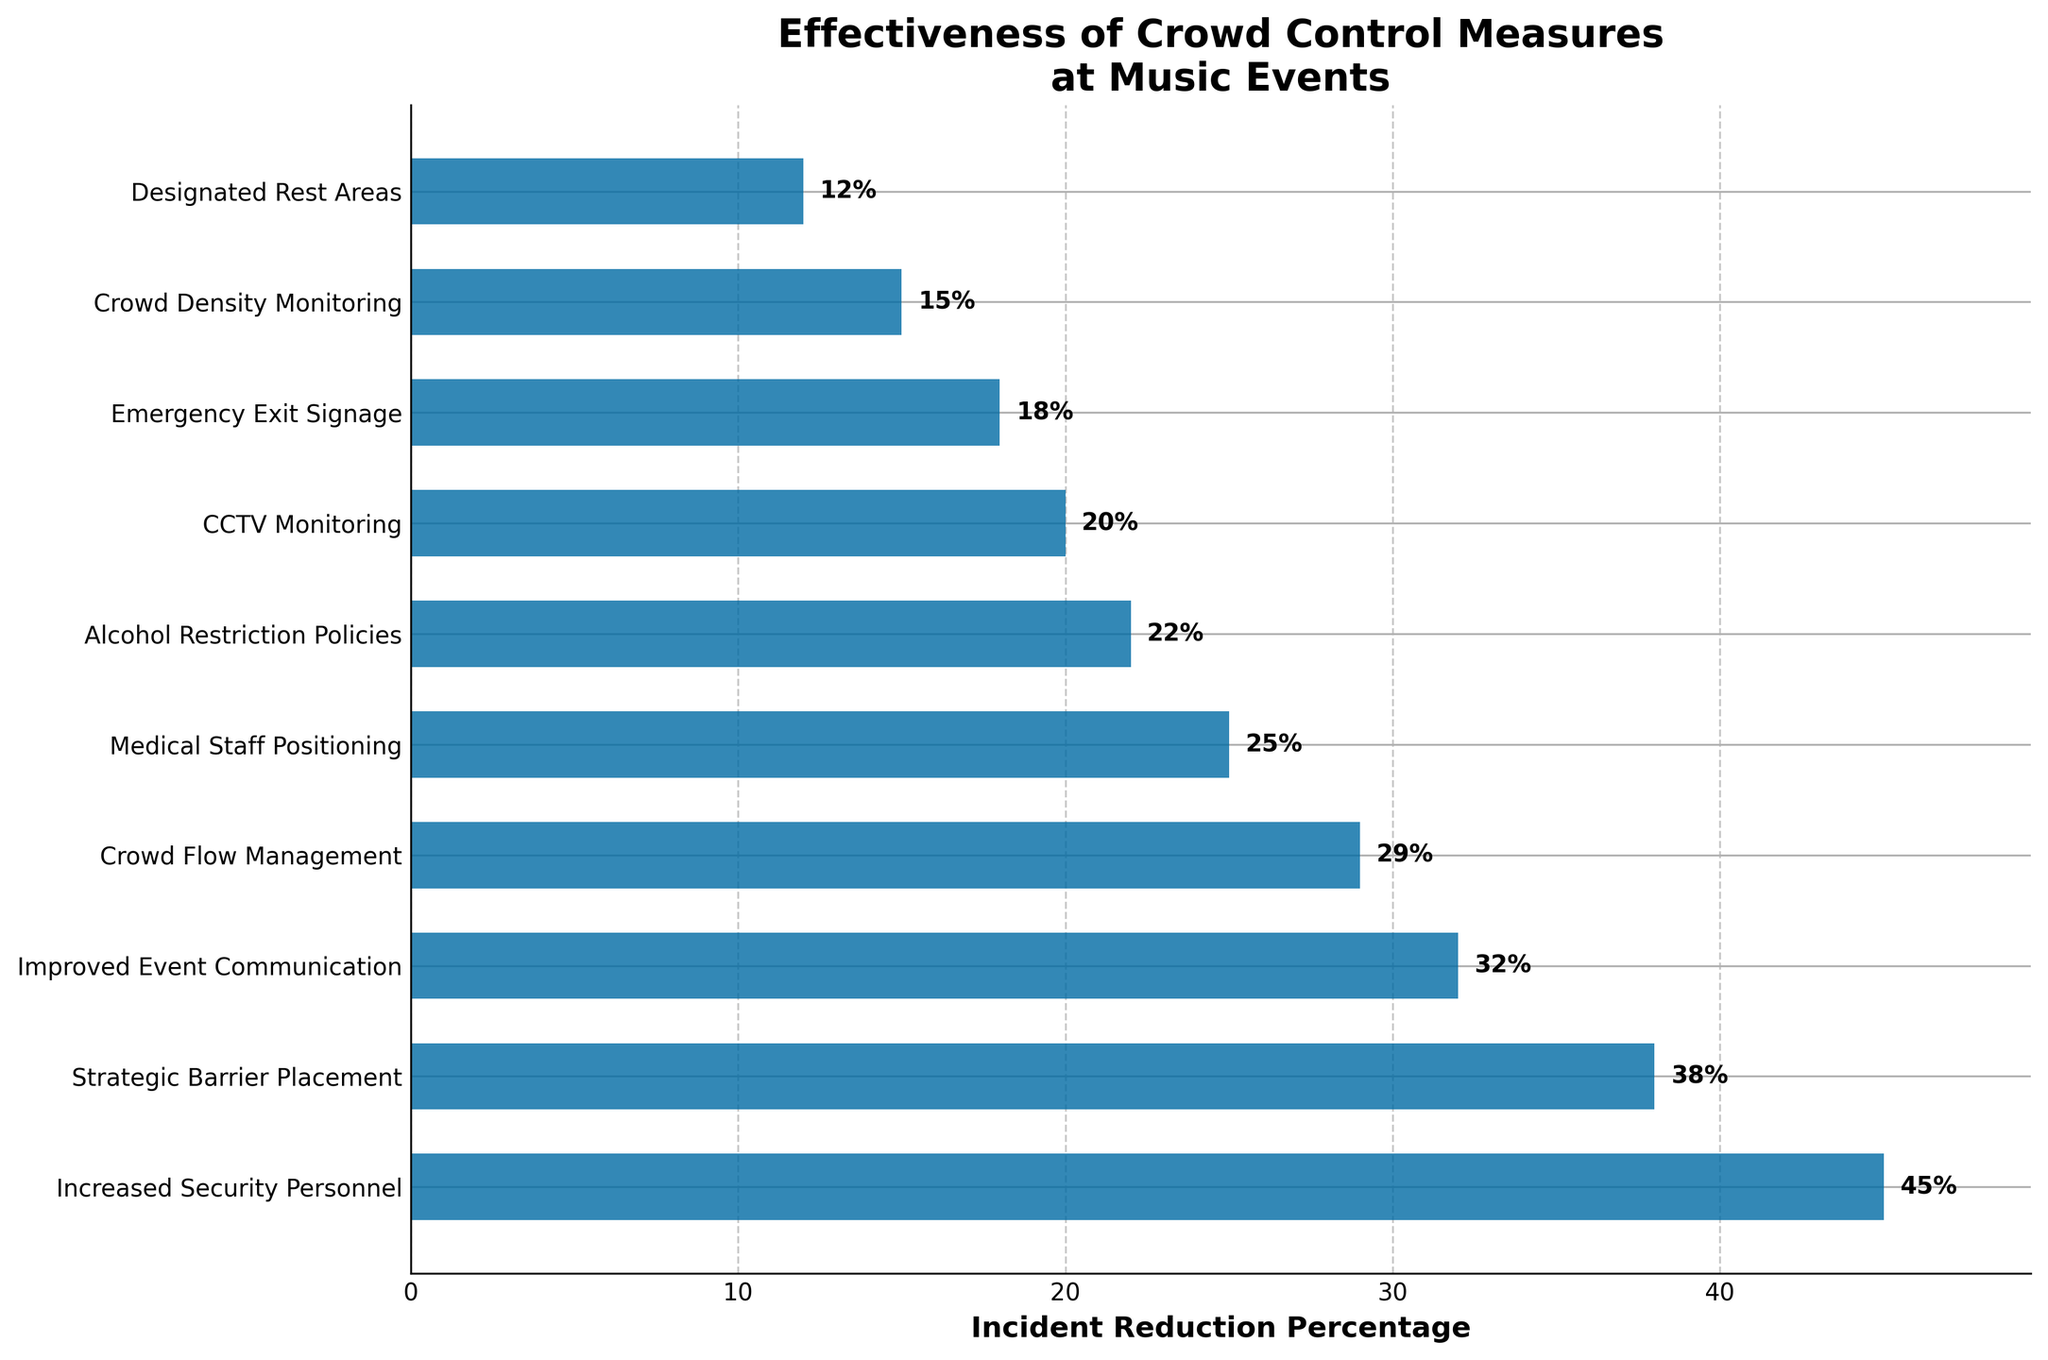Which crowd control measure is the most effective in reducing incidents at music events? The highest bar in the chart represents the most effective measure. Here, 'Increased Security Personnel' reduces incidents by 45%, making it the most effective.
Answer: Increased Security Personnel Compare the effectiveness of 'Strategic Barrier Placement' and 'Improved Event Communication'. According to the bar lengths, 'Strategic Barrier Placement' reduces incidents by 38% and 'Improved Event Communication' by 32%. 'Strategic Barrier Placement' is more effective.
Answer: Strategic Barrier Placement By how much does 'Medical Staff Positioning' reduce incidents compared to 'Alcohol Restriction Policies'? The chart shows 'Medical Staff Positioning' reduces incidents by 25% and 'Alcohol Restriction Policies' by 22%. The difference is 25% - 22% = 3%.
Answer: 3% What is the combined effectiveness of 'CCTV Monitoring' and 'Emergency Exit Signage'? From the chart, 'CCTV Monitoring' is 20% effective, and 'Emergency Exit Signage' is 18% effective. Combined, they are 20% + 18% = 38% effective.
Answer: 38% Which measure has the smallest incident reduction percentage, and what is it? The smallest bar represents 'Designated Rest Areas,' which has a 12% reduction in incidents.
Answer: Designated Rest Areas, 12% Order the measures from most effective to least effective. List all measures based on the height of their bars from highest to lowest: Increased Security Personnel, Strategic Barrier Placement, Improved Event Communication, Crowd Flow Management, Medical Staff Positioning, Alcohol Restriction Policies, CCTV Monitoring, Emergency Exit Signage, Crowd Density Monitoring, Designated Rest Areas.
Answer: Increased Security Personnel, Strategic Barrier Placement, Improved Event Communication, Crowd Flow Management, Medical Staff Positioning, Alcohol Restriction Policies, CCTV Monitoring, Emergency Exit Signage, Crowd Density Monitoring, Designated Rest Areas Which measure is 10% more effective than 'Designated Rest Areas'? 'Designated Rest Areas' has a 12% reduction. The measure that is 10% more effective would therefore have a 22% reduction. From the chart, this measure is 'Alcohol Restriction Policies.'
Answer: Alcohol Restriction Policies What is the total percentage reduction in incidents if all measures are used together? Sum all the reduction percentages: 45% (Increased Security Personnel) + 38% (Strategic Barrier Placement) + 32% (Improved Event Communication) + 29% (Crowd Flow Management) + 25% (Medical Staff Positioning) + 22% (Alcohol Restriction Policies) + 20% (CCTV Monitoring) + 18% (Emergency Exit Signage) + 15% (Crowd Density Monitoring) + 12% (Designated Rest Areas) = 256%.
Answer: 256% 